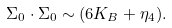<formula> <loc_0><loc_0><loc_500><loc_500>\Sigma _ { 0 } \cdot \Sigma _ { 0 } \sim ( 6 K _ { B } + \eta _ { 4 } ) .</formula> 